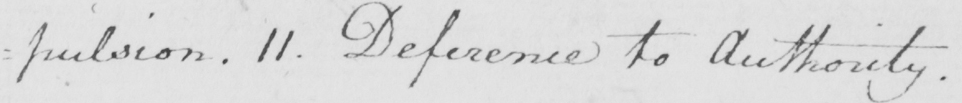Can you tell me what this handwritten text says? : pulsion . 11 . Deference to Authority . 